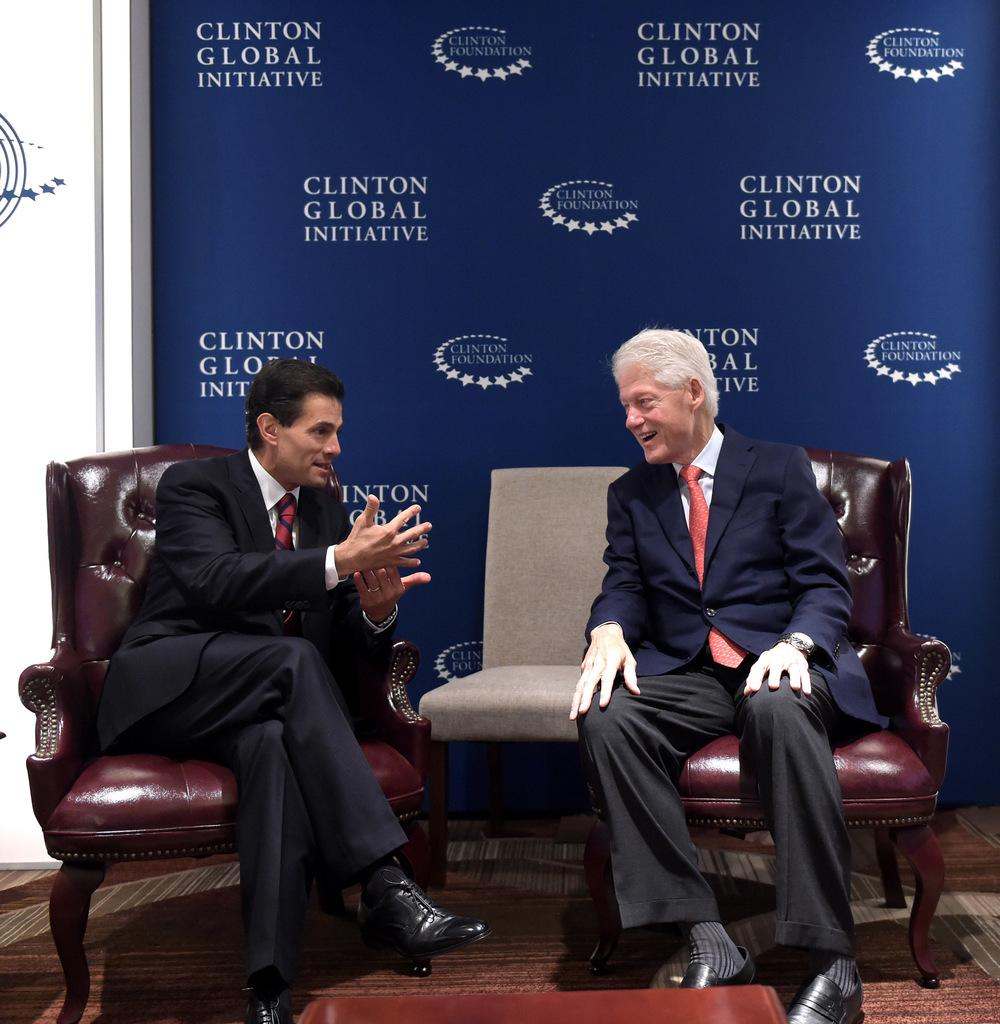How many people are in the image? There are two persons in the image. What are the two persons doing in the image? The two persons are sitting on chairs. What type of branch is the writer using to write on the secretary's desk in the image? There is no writer, secretary, or desk present in the image; it only features two persons sitting on chairs. 